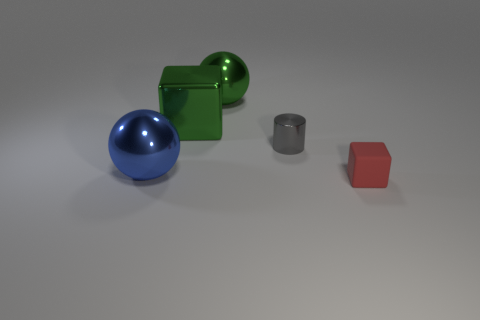How would you describe the lighting in the image? The lighting in the image is soft and diffused, with subtle shadows indicating a light source from above, likely simulating a natural or studio lighting environment. 